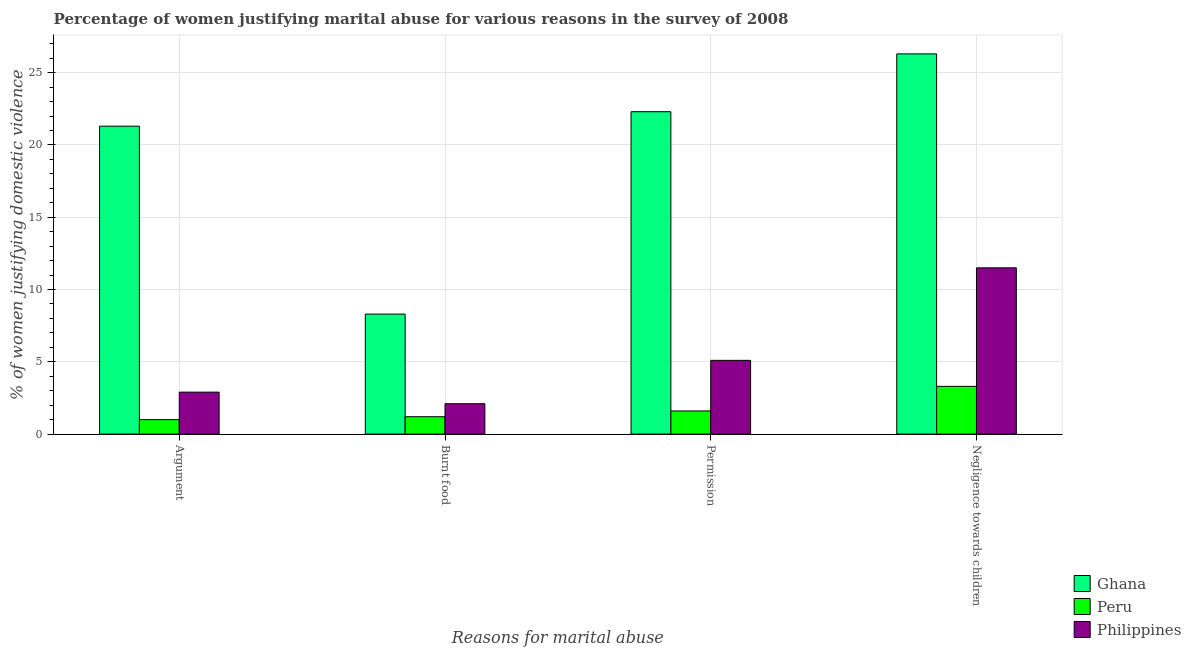How many different coloured bars are there?
Your answer should be compact. 3. How many groups of bars are there?
Your answer should be very brief. 4. What is the label of the 4th group of bars from the left?
Offer a terse response. Negligence towards children. What is the percentage of women justifying abuse for going without permission in Ghana?
Offer a very short reply. 22.3. Across all countries, what is the maximum percentage of women justifying abuse for going without permission?
Give a very brief answer. 22.3. In which country was the percentage of women justifying abuse for going without permission maximum?
Your response must be concise. Ghana. What is the difference between the percentage of women justifying abuse for burning food in Peru and that in Philippines?
Offer a very short reply. -0.9. What is the difference between the percentage of women justifying abuse in the case of an argument in Peru and the percentage of women justifying abuse for burning food in Ghana?
Give a very brief answer. -7.3. What is the average percentage of women justifying abuse in the case of an argument per country?
Provide a short and direct response. 8.4. What is the difference between the percentage of women justifying abuse for burning food and percentage of women justifying abuse for showing negligence towards children in Peru?
Provide a short and direct response. -2.1. What is the ratio of the percentage of women justifying abuse in the case of an argument in Peru to that in Ghana?
Your answer should be compact. 0.05. Is the percentage of women justifying abuse for showing negligence towards children in Ghana less than that in Philippines?
Offer a terse response. No. What is the difference between the highest and the second highest percentage of women justifying abuse in the case of an argument?
Make the answer very short. 18.4. What is the difference between the highest and the lowest percentage of women justifying abuse in the case of an argument?
Ensure brevity in your answer.  20.3. In how many countries, is the percentage of women justifying abuse for going without permission greater than the average percentage of women justifying abuse for going without permission taken over all countries?
Make the answer very short. 1. Is the sum of the percentage of women justifying abuse for showing negligence towards children in Peru and Philippines greater than the maximum percentage of women justifying abuse for burning food across all countries?
Provide a succinct answer. Yes. Is it the case that in every country, the sum of the percentage of women justifying abuse for showing negligence towards children and percentage of women justifying abuse for going without permission is greater than the sum of percentage of women justifying abuse in the case of an argument and percentage of women justifying abuse for burning food?
Give a very brief answer. No. What does the 1st bar from the left in Burnt food represents?
Keep it short and to the point. Ghana. What does the 1st bar from the right in Burnt food represents?
Give a very brief answer. Philippines. Is it the case that in every country, the sum of the percentage of women justifying abuse in the case of an argument and percentage of women justifying abuse for burning food is greater than the percentage of women justifying abuse for going without permission?
Keep it short and to the point. No. How many countries are there in the graph?
Your answer should be very brief. 3. Are the values on the major ticks of Y-axis written in scientific E-notation?
Your answer should be very brief. No. Where does the legend appear in the graph?
Offer a terse response. Bottom right. What is the title of the graph?
Your answer should be very brief. Percentage of women justifying marital abuse for various reasons in the survey of 2008. What is the label or title of the X-axis?
Your answer should be very brief. Reasons for marital abuse. What is the label or title of the Y-axis?
Keep it short and to the point. % of women justifying domestic violence. What is the % of women justifying domestic violence in Ghana in Argument?
Make the answer very short. 21.3. What is the % of women justifying domestic violence in Peru in Argument?
Keep it short and to the point. 1. What is the % of women justifying domestic violence in Philippines in Argument?
Make the answer very short. 2.9. What is the % of women justifying domestic violence in Peru in Burnt food?
Your answer should be compact. 1.2. What is the % of women justifying domestic violence of Ghana in Permission?
Your answer should be very brief. 22.3. What is the % of women justifying domestic violence in Peru in Permission?
Keep it short and to the point. 1.6. What is the % of women justifying domestic violence in Philippines in Permission?
Offer a terse response. 5.1. What is the % of women justifying domestic violence of Ghana in Negligence towards children?
Ensure brevity in your answer.  26.3. What is the % of women justifying domestic violence of Philippines in Negligence towards children?
Give a very brief answer. 11.5. Across all Reasons for marital abuse, what is the maximum % of women justifying domestic violence in Ghana?
Offer a very short reply. 26.3. Across all Reasons for marital abuse, what is the maximum % of women justifying domestic violence in Philippines?
Offer a very short reply. 11.5. Across all Reasons for marital abuse, what is the minimum % of women justifying domestic violence of Peru?
Your answer should be very brief. 1. Across all Reasons for marital abuse, what is the minimum % of women justifying domestic violence of Philippines?
Make the answer very short. 2.1. What is the total % of women justifying domestic violence in Ghana in the graph?
Offer a very short reply. 78.2. What is the total % of women justifying domestic violence in Peru in the graph?
Make the answer very short. 7.1. What is the total % of women justifying domestic violence in Philippines in the graph?
Offer a very short reply. 21.6. What is the difference between the % of women justifying domestic violence in Peru in Argument and that in Permission?
Keep it short and to the point. -0.6. What is the difference between the % of women justifying domestic violence in Philippines in Argument and that in Permission?
Keep it short and to the point. -2.2. What is the difference between the % of women justifying domestic violence of Peru in Burnt food and that in Permission?
Keep it short and to the point. -0.4. What is the difference between the % of women justifying domestic violence of Ghana in Permission and that in Negligence towards children?
Offer a terse response. -4. What is the difference between the % of women justifying domestic violence in Peru in Permission and that in Negligence towards children?
Provide a succinct answer. -1.7. What is the difference between the % of women justifying domestic violence in Philippines in Permission and that in Negligence towards children?
Provide a short and direct response. -6.4. What is the difference between the % of women justifying domestic violence of Ghana in Argument and the % of women justifying domestic violence of Peru in Burnt food?
Give a very brief answer. 20.1. What is the difference between the % of women justifying domestic violence in Ghana in Argument and the % of women justifying domestic violence in Philippines in Burnt food?
Offer a terse response. 19.2. What is the difference between the % of women justifying domestic violence of Peru in Argument and the % of women justifying domestic violence of Philippines in Burnt food?
Offer a terse response. -1.1. What is the difference between the % of women justifying domestic violence of Ghana in Argument and the % of women justifying domestic violence of Philippines in Negligence towards children?
Offer a terse response. 9.8. What is the difference between the % of women justifying domestic violence in Ghana in Burnt food and the % of women justifying domestic violence in Peru in Permission?
Make the answer very short. 6.7. What is the difference between the % of women justifying domestic violence of Peru in Burnt food and the % of women justifying domestic violence of Philippines in Permission?
Make the answer very short. -3.9. What is the difference between the % of women justifying domestic violence in Ghana in Burnt food and the % of women justifying domestic violence in Philippines in Negligence towards children?
Ensure brevity in your answer.  -3.2. What is the difference between the % of women justifying domestic violence of Peru in Burnt food and the % of women justifying domestic violence of Philippines in Negligence towards children?
Provide a succinct answer. -10.3. What is the difference between the % of women justifying domestic violence in Ghana in Permission and the % of women justifying domestic violence in Peru in Negligence towards children?
Your answer should be very brief. 19. What is the difference between the % of women justifying domestic violence in Peru in Permission and the % of women justifying domestic violence in Philippines in Negligence towards children?
Your answer should be compact. -9.9. What is the average % of women justifying domestic violence in Ghana per Reasons for marital abuse?
Your response must be concise. 19.55. What is the average % of women justifying domestic violence in Peru per Reasons for marital abuse?
Ensure brevity in your answer.  1.77. What is the difference between the % of women justifying domestic violence of Ghana and % of women justifying domestic violence of Peru in Argument?
Offer a terse response. 20.3. What is the difference between the % of women justifying domestic violence in Peru and % of women justifying domestic violence in Philippines in Argument?
Offer a terse response. -1.9. What is the difference between the % of women justifying domestic violence of Ghana and % of women justifying domestic violence of Peru in Burnt food?
Provide a short and direct response. 7.1. What is the difference between the % of women justifying domestic violence of Ghana and % of women justifying domestic violence of Philippines in Burnt food?
Offer a very short reply. 6.2. What is the difference between the % of women justifying domestic violence of Peru and % of women justifying domestic violence of Philippines in Burnt food?
Ensure brevity in your answer.  -0.9. What is the difference between the % of women justifying domestic violence in Ghana and % of women justifying domestic violence in Peru in Permission?
Provide a short and direct response. 20.7. What is the difference between the % of women justifying domestic violence in Peru and % of women justifying domestic violence in Philippines in Negligence towards children?
Your answer should be very brief. -8.2. What is the ratio of the % of women justifying domestic violence of Ghana in Argument to that in Burnt food?
Provide a short and direct response. 2.57. What is the ratio of the % of women justifying domestic violence in Peru in Argument to that in Burnt food?
Offer a very short reply. 0.83. What is the ratio of the % of women justifying domestic violence in Philippines in Argument to that in Burnt food?
Make the answer very short. 1.38. What is the ratio of the % of women justifying domestic violence of Ghana in Argument to that in Permission?
Your response must be concise. 0.96. What is the ratio of the % of women justifying domestic violence in Peru in Argument to that in Permission?
Provide a short and direct response. 0.62. What is the ratio of the % of women justifying domestic violence in Philippines in Argument to that in Permission?
Provide a short and direct response. 0.57. What is the ratio of the % of women justifying domestic violence of Ghana in Argument to that in Negligence towards children?
Give a very brief answer. 0.81. What is the ratio of the % of women justifying domestic violence in Peru in Argument to that in Negligence towards children?
Provide a succinct answer. 0.3. What is the ratio of the % of women justifying domestic violence of Philippines in Argument to that in Negligence towards children?
Keep it short and to the point. 0.25. What is the ratio of the % of women justifying domestic violence of Ghana in Burnt food to that in Permission?
Provide a short and direct response. 0.37. What is the ratio of the % of women justifying domestic violence in Philippines in Burnt food to that in Permission?
Provide a succinct answer. 0.41. What is the ratio of the % of women justifying domestic violence in Ghana in Burnt food to that in Negligence towards children?
Give a very brief answer. 0.32. What is the ratio of the % of women justifying domestic violence of Peru in Burnt food to that in Negligence towards children?
Offer a terse response. 0.36. What is the ratio of the % of women justifying domestic violence in Philippines in Burnt food to that in Negligence towards children?
Keep it short and to the point. 0.18. What is the ratio of the % of women justifying domestic violence in Ghana in Permission to that in Negligence towards children?
Provide a short and direct response. 0.85. What is the ratio of the % of women justifying domestic violence of Peru in Permission to that in Negligence towards children?
Offer a terse response. 0.48. What is the ratio of the % of women justifying domestic violence in Philippines in Permission to that in Negligence towards children?
Your answer should be compact. 0.44. What is the difference between the highest and the second highest % of women justifying domestic violence in Ghana?
Ensure brevity in your answer.  4. What is the difference between the highest and the second highest % of women justifying domestic violence of Peru?
Provide a succinct answer. 1.7. What is the difference between the highest and the lowest % of women justifying domestic violence in Ghana?
Provide a succinct answer. 18. What is the difference between the highest and the lowest % of women justifying domestic violence of Philippines?
Give a very brief answer. 9.4. 